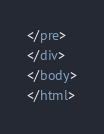Convert code to text. <code><loc_0><loc_0><loc_500><loc_500><_HTML_>








































</pre>
</div>
</body>
</html>
</code> 